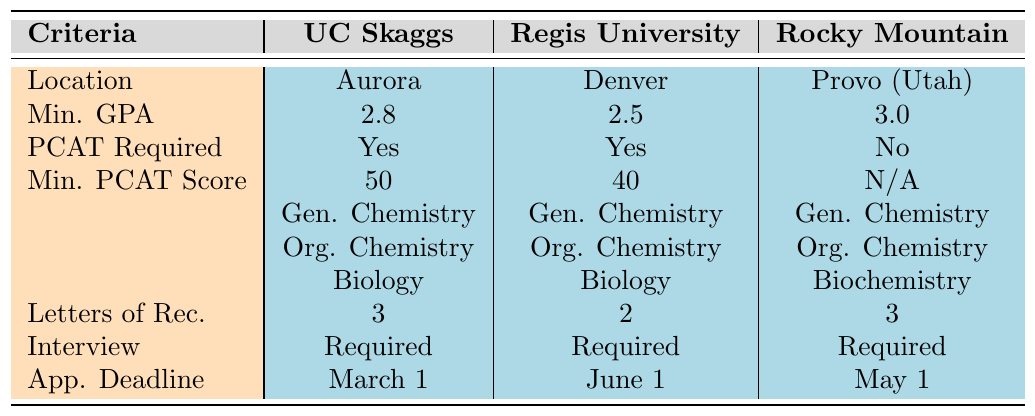What is the minimum GPA required for admission to Regis University School of Pharmacy? The table lists the minimum GPA for Regis University School of Pharmacy as 2.5.
Answer: 2.5 Is the PCAT required for Rocky Mountain University of Health Professions? The table indicates that the PCAT is not required for Rocky Mountain University of Health Professions.
Answer: No How many letters of recommendation are needed for the University of Colorado Skaggs School of Pharmacy? The table specifies that 3 letters of recommendation are required for the University of Colorado Skaggs School of Pharmacy.
Answer: 3 Which university has the highest minimum GPA requirement? By comparing the minimum GPA values (2.8 for UC Skaggs, 2.5 for Regis, and 3.0 for Rocky Mountain), Rocky Mountain has the highest at 3.0.
Answer: Rocky Mountain University What are the prerequisite courses required by Regis University? The table shows that the prerequisite courses for Regis University are General Chemistry, Organic Chemistry, Biology, Anatomy, Physiology, and Physics.
Answer: General Chemistry, Organic Chemistry, Biology, Anatomy, Physiology, Physics Which university has the earliest application deadline? The application deadlines are March 1 for UC Skaggs, June 1 for Regis, and May 1 for Rocky Mountain. March 1 is the earliest.
Answer: University of Colorado Skaggs School of Pharmacy How many prerequisite courses are required for the admissions at Rocky Mountain University? The table lists 6 prerequisite courses for Rocky Mountain University, which include General Chemistry, Organic Chemistry, Biochemistry, Anatomy, Physiology, and Microbiology.
Answer: 6 Is an interview required for admission to all listed pharmacy schools? The table shows that an interview is required for University of Colorado Skaggs, Regis University, and Rocky Mountain University, indicating that the requirement holds true for all.
Answer: Yes What is the difference between the minimum PCAT composite scores for the two universities that require it? The minimum PCAT scores are 50 for UC Skaggs and 40 for Regis, so the difference is 50 - 40 = 10.
Answer: 10 Which university has the latest application deadline among those listed? The application deadlines are March 1 for UC Skaggs, June 1 for Regis, and May 1 for Rocky Mountain, making June 1 the latest deadline at Regis University.
Answer: Regis University School of Pharmacy 